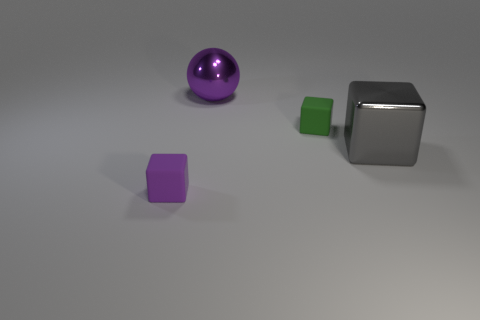The purple thing that is behind the block that is left of the large sphere is made of what material?
Keep it short and to the point. Metal. What material is the big gray object that is on the right side of the small purple rubber block?
Your response must be concise. Metal. Do the large gray metallic thing and the big thing on the left side of the gray cube have the same shape?
Your answer should be very brief. No. What is the shape of the object that is right of the purple metal thing and behind the large shiny block?
Offer a terse response. Cube. Are there an equal number of gray shiny cubes that are left of the tiny green rubber object and rubber cubes that are in front of the big purple thing?
Keep it short and to the point. No. Do the matte object that is behind the big metallic cube and the big purple metallic thing have the same shape?
Your answer should be compact. No. How many blue things are either large objects or metallic blocks?
Your answer should be very brief. 0. There is another big object that is the same shape as the green thing; what is it made of?
Give a very brief answer. Metal. There is a small object that is in front of the metal block; what is its shape?
Make the answer very short. Cube. Is there a big sphere that has the same material as the small green block?
Your answer should be compact. No. 